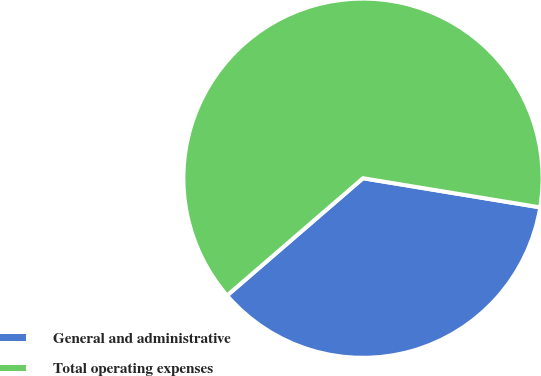Convert chart. <chart><loc_0><loc_0><loc_500><loc_500><pie_chart><fcel>General and administrative<fcel>Total operating expenses<nl><fcel>36.07%<fcel>63.93%<nl></chart> 